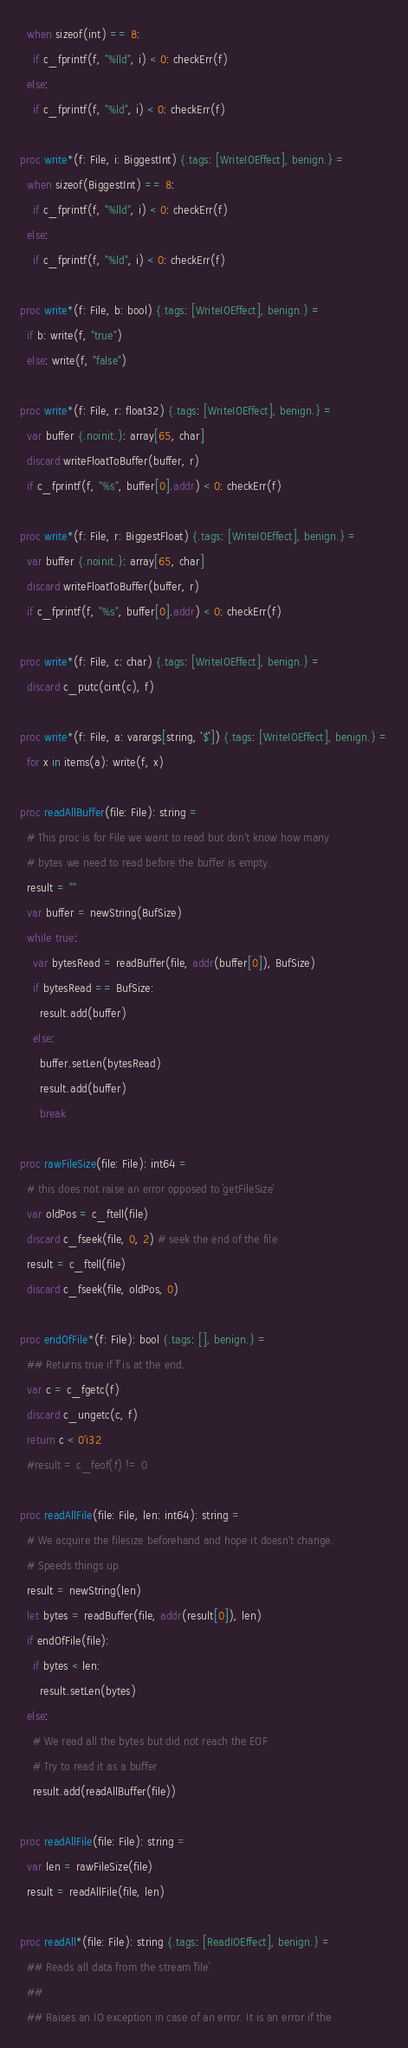<code> <loc_0><loc_0><loc_500><loc_500><_Nim_>  when sizeof(int) == 8:
    if c_fprintf(f, "%lld", i) < 0: checkErr(f)
  else:
    if c_fprintf(f, "%ld", i) < 0: checkErr(f)

proc write*(f: File, i: BiggestInt) {.tags: [WriteIOEffect], benign.} =
  when sizeof(BiggestInt) == 8:
    if c_fprintf(f, "%lld", i) < 0: checkErr(f)
  else:
    if c_fprintf(f, "%ld", i) < 0: checkErr(f)

proc write*(f: File, b: bool) {.tags: [WriteIOEffect], benign.} =
  if b: write(f, "true")
  else: write(f, "false")

proc write*(f: File, r: float32) {.tags: [WriteIOEffect], benign.} =
  var buffer {.noinit.}: array[65, char]
  discard writeFloatToBuffer(buffer, r)
  if c_fprintf(f, "%s", buffer[0].addr) < 0: checkErr(f)

proc write*(f: File, r: BiggestFloat) {.tags: [WriteIOEffect], benign.} =
  var buffer {.noinit.}: array[65, char]
  discard writeFloatToBuffer(buffer, r)
  if c_fprintf(f, "%s", buffer[0].addr) < 0: checkErr(f)

proc write*(f: File, c: char) {.tags: [WriteIOEffect], benign.} =
  discard c_putc(cint(c), f)

proc write*(f: File, a: varargs[string, `$`]) {.tags: [WriteIOEffect], benign.} =
  for x in items(a): write(f, x)

proc readAllBuffer(file: File): string =
  # This proc is for File we want to read but don't know how many
  # bytes we need to read before the buffer is empty.
  result = ""
  var buffer = newString(BufSize)
  while true:
    var bytesRead = readBuffer(file, addr(buffer[0]), BufSize)
    if bytesRead == BufSize:
      result.add(buffer)
    else:
      buffer.setLen(bytesRead)
      result.add(buffer)
      break

proc rawFileSize(file: File): int64 =
  # this does not raise an error opposed to `getFileSize`
  var oldPos = c_ftell(file)
  discard c_fseek(file, 0, 2) # seek the end of the file
  result = c_ftell(file)
  discard c_fseek(file, oldPos, 0)

proc endOfFile*(f: File): bool {.tags: [], benign.} =
  ## Returns true if `f` is at the end.
  var c = c_fgetc(f)
  discard c_ungetc(c, f)
  return c < 0'i32
  #result = c_feof(f) != 0

proc readAllFile(file: File, len: int64): string =
  # We acquire the filesize beforehand and hope it doesn't change.
  # Speeds things up.
  result = newString(len)
  let bytes = readBuffer(file, addr(result[0]), len)
  if endOfFile(file):
    if bytes < len:
      result.setLen(bytes)
  else:
    # We read all the bytes but did not reach the EOF
    # Try to read it as a buffer
    result.add(readAllBuffer(file))

proc readAllFile(file: File): string =
  var len = rawFileSize(file)
  result = readAllFile(file, len)

proc readAll*(file: File): string {.tags: [ReadIOEffect], benign.} =
  ## Reads all data from the stream `file`.
  ##
  ## Raises an IO exception in case of an error. It is an error if the</code> 